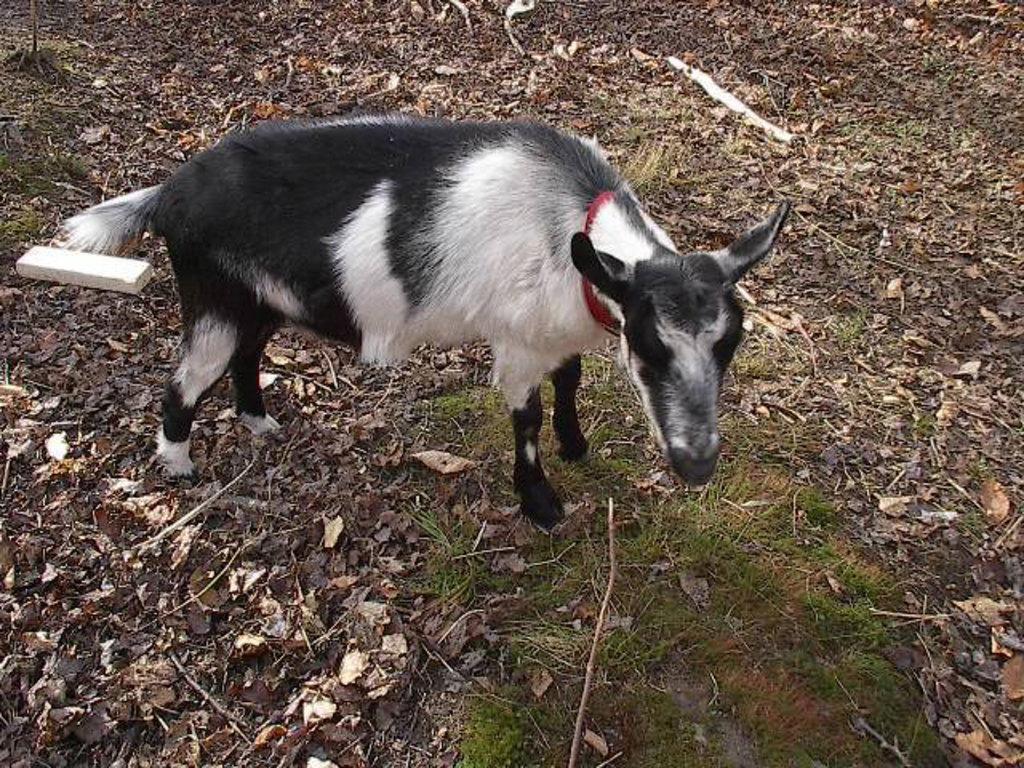Can you describe this image briefly? In this picture there is a goat which is in black and white color and there is a greenery ground in front of it and there are few dried leaves around it. 